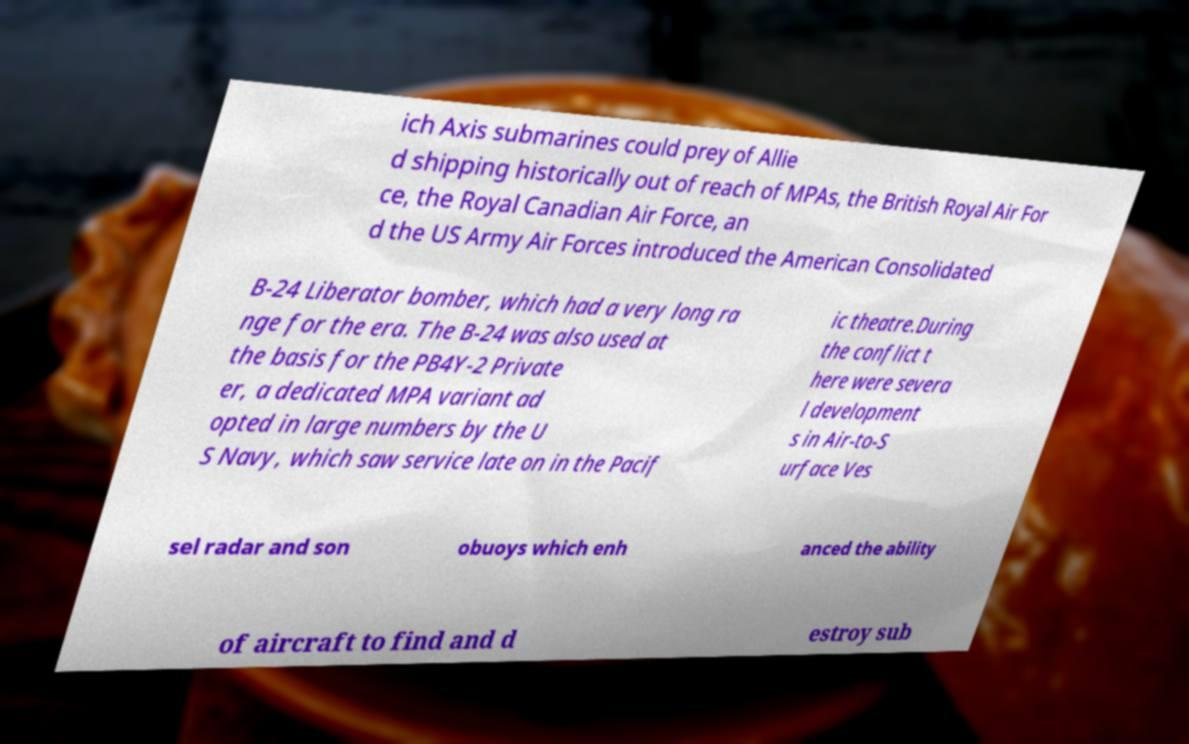Can you accurately transcribe the text from the provided image for me? ich Axis submarines could prey of Allie d shipping historically out of reach of MPAs, the British Royal Air For ce, the Royal Canadian Air Force, an d the US Army Air Forces introduced the American Consolidated B-24 Liberator bomber, which had a very long ra nge for the era. The B-24 was also used at the basis for the PB4Y-2 Private er, a dedicated MPA variant ad opted in large numbers by the U S Navy, which saw service late on in the Pacif ic theatre.During the conflict t here were severa l development s in Air-to-S urface Ves sel radar and son obuoys which enh anced the ability of aircraft to find and d estroy sub 